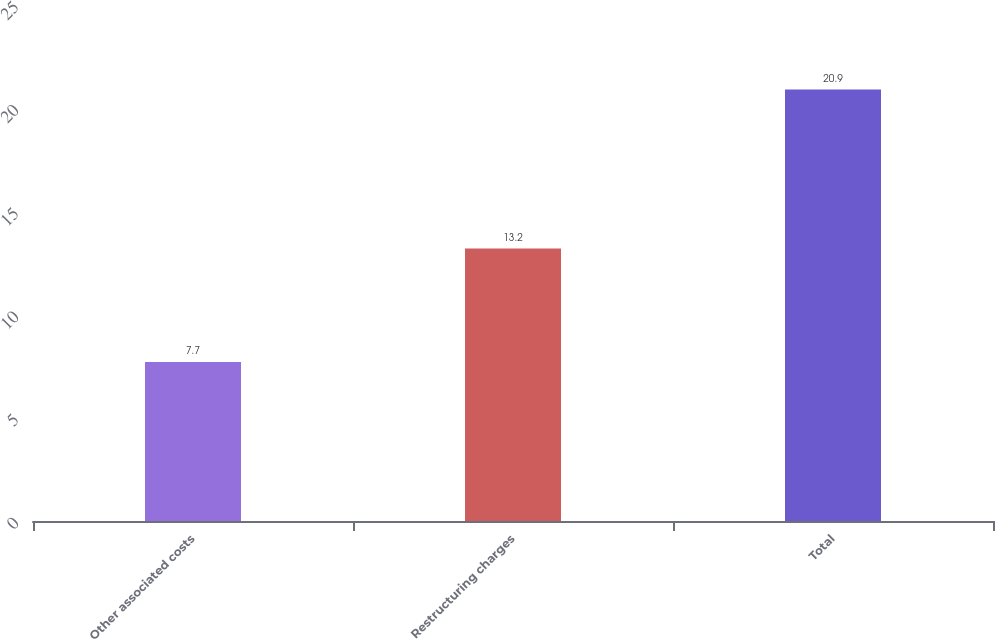Convert chart. <chart><loc_0><loc_0><loc_500><loc_500><bar_chart><fcel>Other associated costs<fcel>Restructuring charges<fcel>Total<nl><fcel>7.7<fcel>13.2<fcel>20.9<nl></chart> 